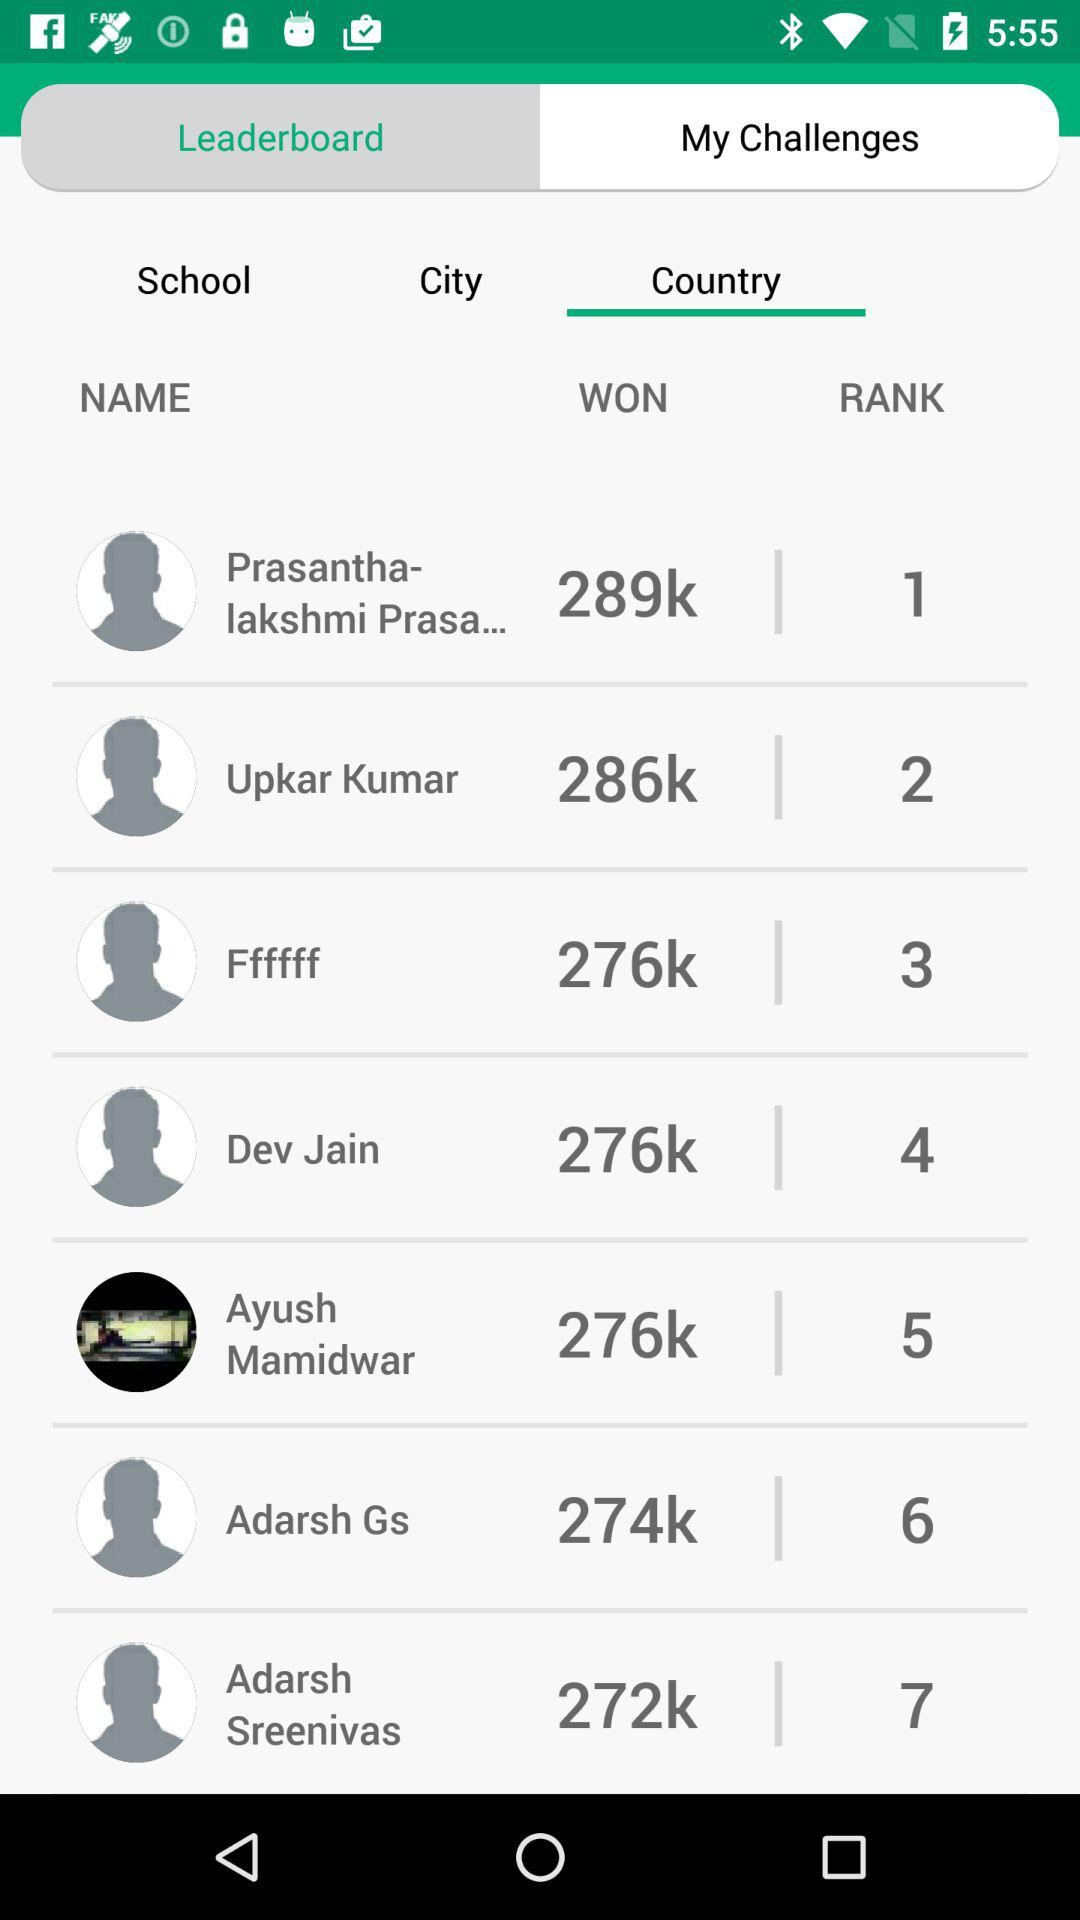What is the rank of Dev Jain? The rank of Dev Jain is 4. 